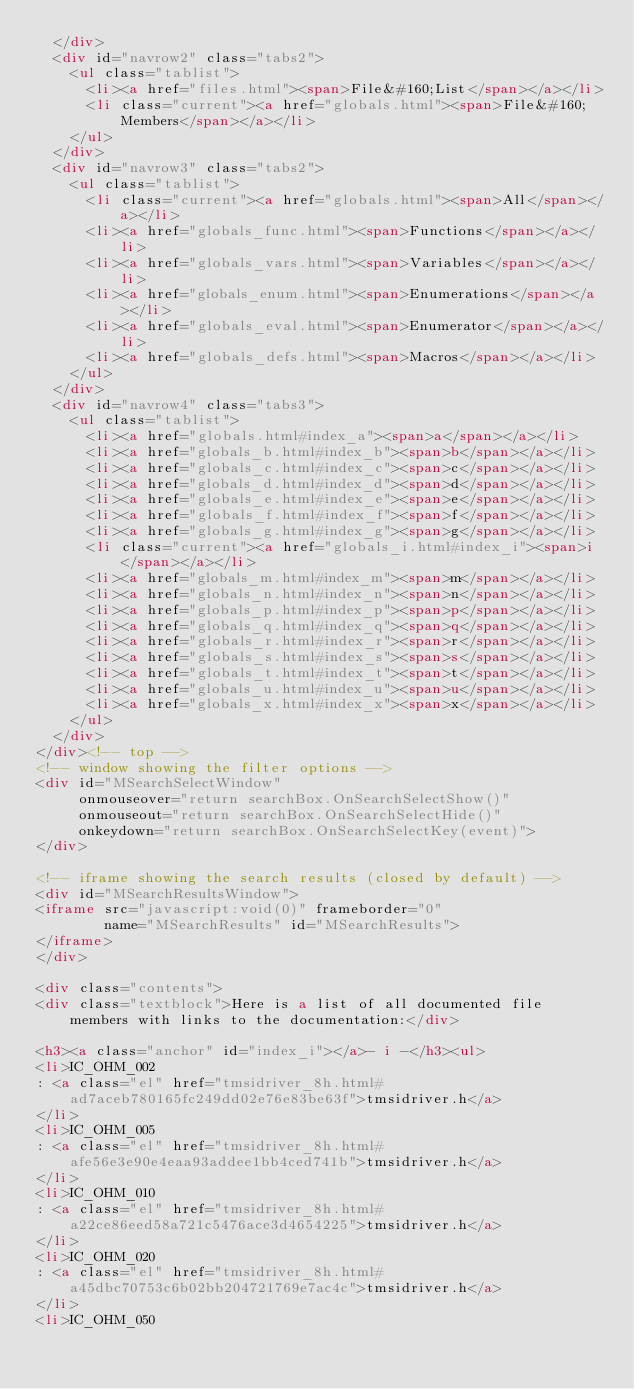<code> <loc_0><loc_0><loc_500><loc_500><_HTML_>  </div>
  <div id="navrow2" class="tabs2">
    <ul class="tablist">
      <li><a href="files.html"><span>File&#160;List</span></a></li>
      <li class="current"><a href="globals.html"><span>File&#160;Members</span></a></li>
    </ul>
  </div>
  <div id="navrow3" class="tabs2">
    <ul class="tablist">
      <li class="current"><a href="globals.html"><span>All</span></a></li>
      <li><a href="globals_func.html"><span>Functions</span></a></li>
      <li><a href="globals_vars.html"><span>Variables</span></a></li>
      <li><a href="globals_enum.html"><span>Enumerations</span></a></li>
      <li><a href="globals_eval.html"><span>Enumerator</span></a></li>
      <li><a href="globals_defs.html"><span>Macros</span></a></li>
    </ul>
  </div>
  <div id="navrow4" class="tabs3">
    <ul class="tablist">
      <li><a href="globals.html#index_a"><span>a</span></a></li>
      <li><a href="globals_b.html#index_b"><span>b</span></a></li>
      <li><a href="globals_c.html#index_c"><span>c</span></a></li>
      <li><a href="globals_d.html#index_d"><span>d</span></a></li>
      <li><a href="globals_e.html#index_e"><span>e</span></a></li>
      <li><a href="globals_f.html#index_f"><span>f</span></a></li>
      <li><a href="globals_g.html#index_g"><span>g</span></a></li>
      <li class="current"><a href="globals_i.html#index_i"><span>i</span></a></li>
      <li><a href="globals_m.html#index_m"><span>m</span></a></li>
      <li><a href="globals_n.html#index_n"><span>n</span></a></li>
      <li><a href="globals_p.html#index_p"><span>p</span></a></li>
      <li><a href="globals_q.html#index_q"><span>q</span></a></li>
      <li><a href="globals_r.html#index_r"><span>r</span></a></li>
      <li><a href="globals_s.html#index_s"><span>s</span></a></li>
      <li><a href="globals_t.html#index_t"><span>t</span></a></li>
      <li><a href="globals_u.html#index_u"><span>u</span></a></li>
      <li><a href="globals_x.html#index_x"><span>x</span></a></li>
    </ul>
  </div>
</div><!-- top -->
<!-- window showing the filter options -->
<div id="MSearchSelectWindow"
     onmouseover="return searchBox.OnSearchSelectShow()"
     onmouseout="return searchBox.OnSearchSelectHide()"
     onkeydown="return searchBox.OnSearchSelectKey(event)">
</div>

<!-- iframe showing the search results (closed by default) -->
<div id="MSearchResultsWindow">
<iframe src="javascript:void(0)" frameborder="0" 
        name="MSearchResults" id="MSearchResults">
</iframe>
</div>

<div class="contents">
<div class="textblock">Here is a list of all documented file members with links to the documentation:</div>

<h3><a class="anchor" id="index_i"></a>- i -</h3><ul>
<li>IC_OHM_002
: <a class="el" href="tmsidriver_8h.html#ad7aceb780165fc249dd02e76e83be63f">tmsidriver.h</a>
</li>
<li>IC_OHM_005
: <a class="el" href="tmsidriver_8h.html#afe56e3e90e4eaa93addee1bb4ced741b">tmsidriver.h</a>
</li>
<li>IC_OHM_010
: <a class="el" href="tmsidriver_8h.html#a22ce86eed58a721c5476ace3d4654225">tmsidriver.h</a>
</li>
<li>IC_OHM_020
: <a class="el" href="tmsidriver_8h.html#a45dbc70753c6b02bb204721769e7ac4c">tmsidriver.h</a>
</li>
<li>IC_OHM_050</code> 